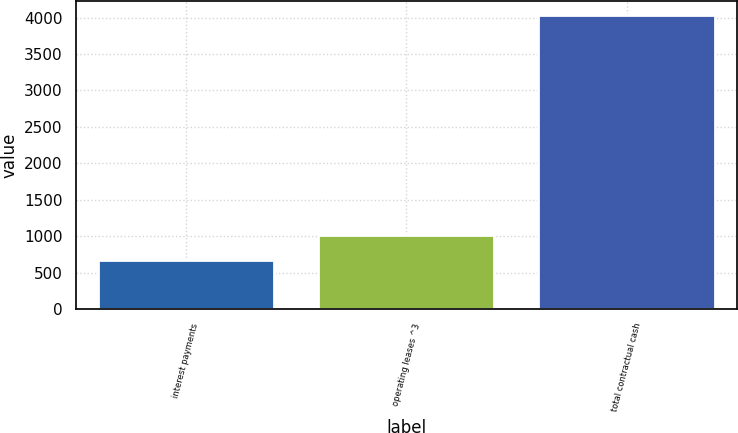<chart> <loc_0><loc_0><loc_500><loc_500><bar_chart><fcel>interest payments<fcel>operating leases ^3<fcel>total contractual cash<nl><fcel>673<fcel>1008.8<fcel>4031<nl></chart> 